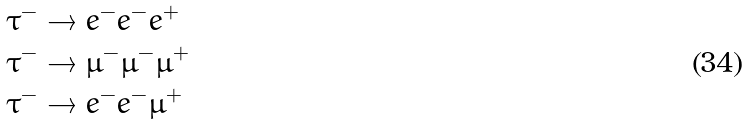Convert formula to latex. <formula><loc_0><loc_0><loc_500><loc_500>\tau ^ { - } & \to e ^ { - } e ^ { - } e ^ { + } \\ \tau ^ { - } & \to \mu ^ { - } \mu ^ { - } \mu ^ { + } \\ \tau ^ { - } & \to e ^ { - } e ^ { - } \mu ^ { + }</formula> 